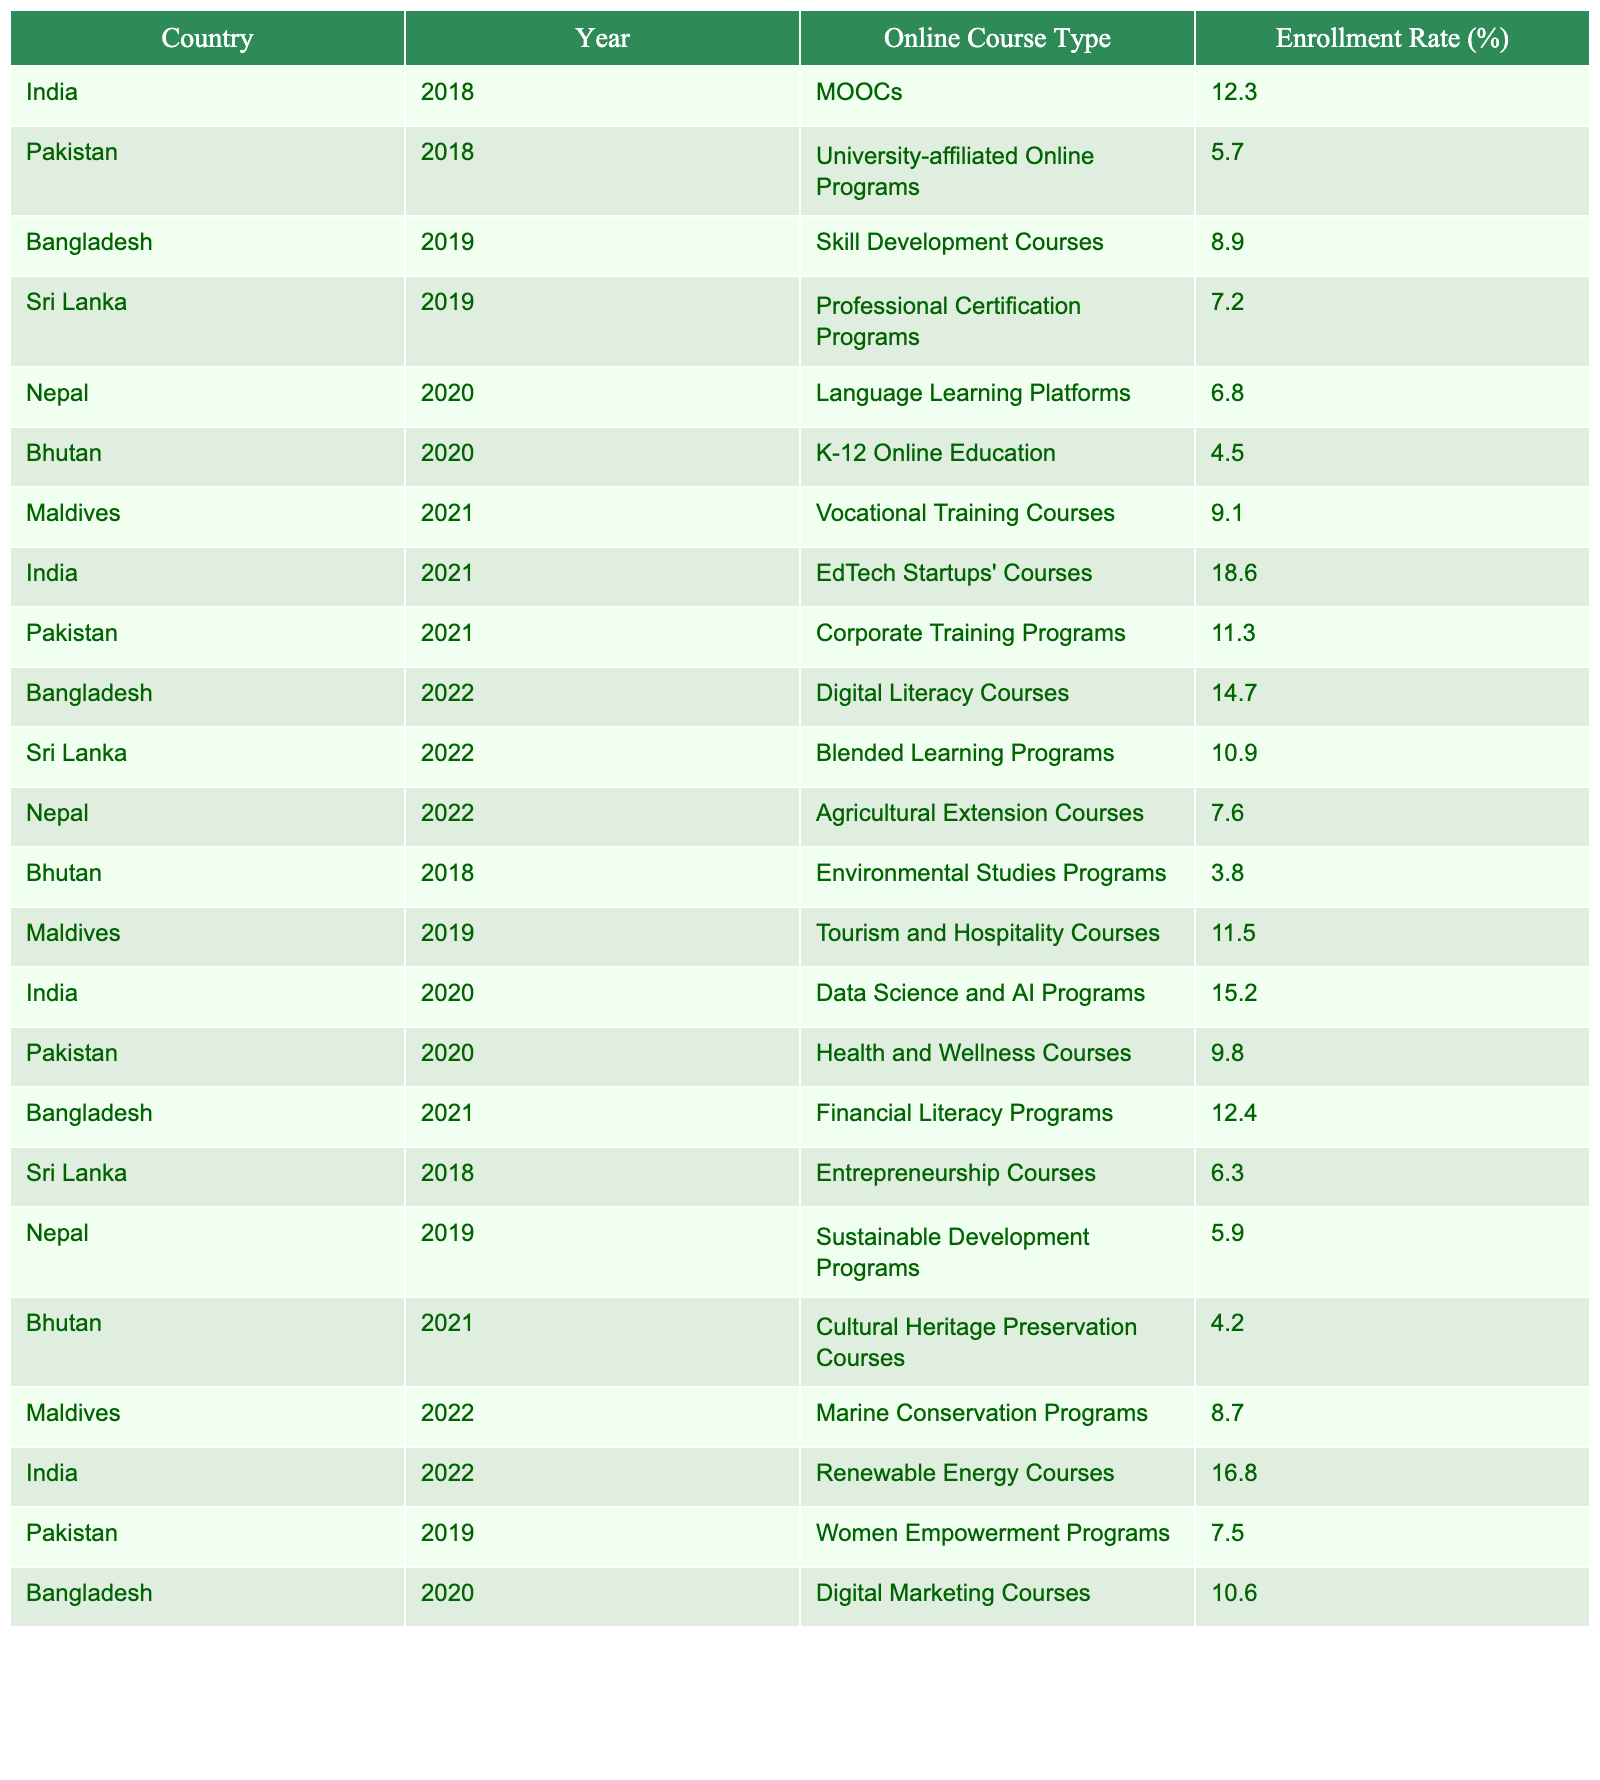What was the enrollment rate for Nepal in 2022? Referring to the table, Nepal's enrollment rate in 2022 shows 7.6% next to the Agricultural Extension Courses.
Answer: 7.6% Which country had the highest enrollment rate in 2021? Looking at the table, India had an enrollment rate of 18.6% with EdTech Startups' Courses in 2021, which is the highest compared to other countries.
Answer: India What was the difference in enrollment rates for MOOCs in India from 2018 to 2022? In 2018, India's enrollment rate for MOOCs was 12.3%, and by 2022 it wasn't listed for MOOCs. So, we can't calculate a difference for the same course type across those years.
Answer: Not applicable Did Bangladesh have any course with an enrollment rate below 10% in 2020? In 2020, Bangladesh's enrollment rate for Digital Marketing Courses was 10.6%, which is above 10%, meaning there were no courses below that threshold.
Answer: No What is the average enrollment rate for courses in Bhutan across all years? Summing Bhutan's enrollment rates: 4.5% (2020) + 3.8% (2018) + 4.2% (2021) = 12.5%. There are 3 data points, so the average is 12.5% / 3 = 4.17%.
Answer: 4.17% Which course type had the least enrollment rate in 2018? The table shows that Bhutan's Environmental Studies Programs had an enrollment rate of 3.8% in 2018, which is the lowest enrollment rate for that year.
Answer: Environmental Studies Programs How did the enrollment rate for Maldives change from 2019 to 2022? In 2019, the enrollment rate was 11.5%, and by 2022 it decreased to 8.7% for Marine Conservation Programs. This indicates a decline of 2.8%.
Answer: Decreased by 2.8% Was there a course type in Pakistan in 2021 that had a higher enrollment rate compared to any 2019 course? In 2021, Pakistan had a corporate training program that had an enrollment rate of 11.3%, and in 2019, the highest was 7.5%, indicating a higher enrollment in 2021.
Answer: Yes What country had the lowest overall enrollment rate across the recorded years? Summing each year's enrollment for each country, Bhutan had the lowest scores in its respective categories, with the lowest recorded rate of 3.8%.
Answer: Bhutan Which online course type showed the most significant increase in enrollment from 2020 to 2022 for India? Comparing India's enrollment for Data Science and AI Programs at 15.2% in 2020 and Renewable Energy Courses at 16.8% in 2022, there is an increase of 1.6%.
Answer: Increased by 1.6% 